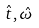Convert formula to latex. <formula><loc_0><loc_0><loc_500><loc_500>\hat { t } , \hat { \omega }</formula> 